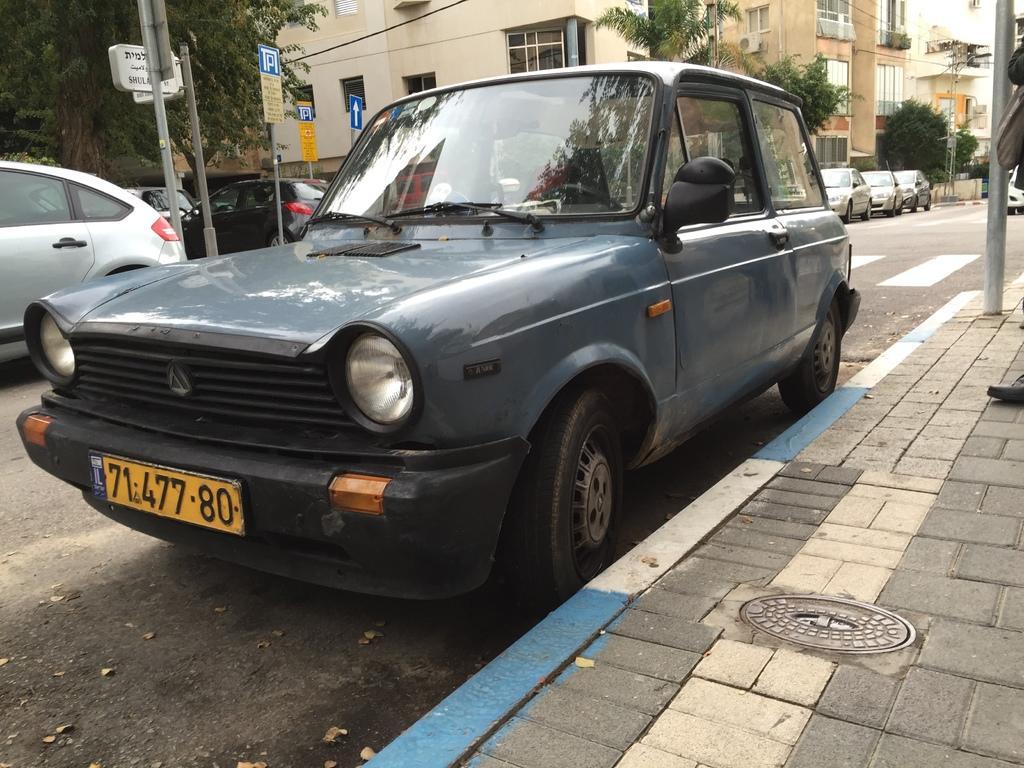How would you summarize this image in a sentence or two? In this image there are some cars in middle of this image and there are some trees at left side of this image and right side of this image as well , and there are some buildings in the background and there is a road in middle of this image. 